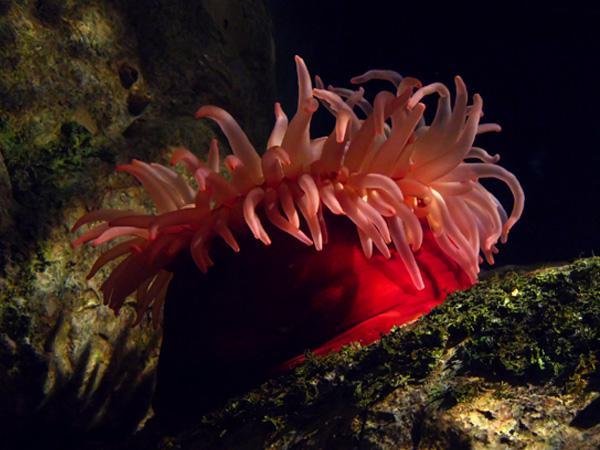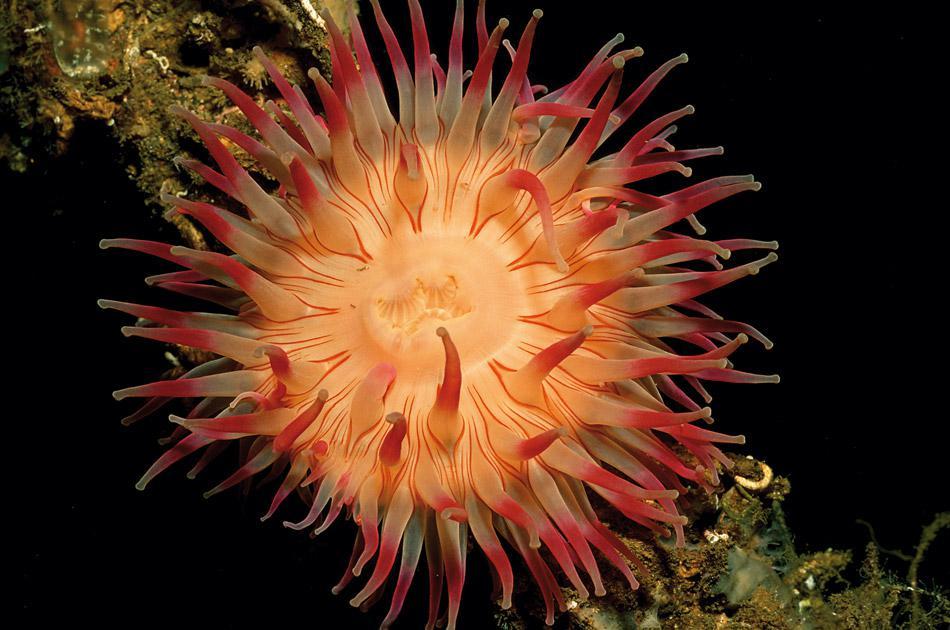The first image is the image on the left, the second image is the image on the right. Analyze the images presented: Is the assertion "There are at least two creatures in the image on the left." valid? Answer yes or no. No. 